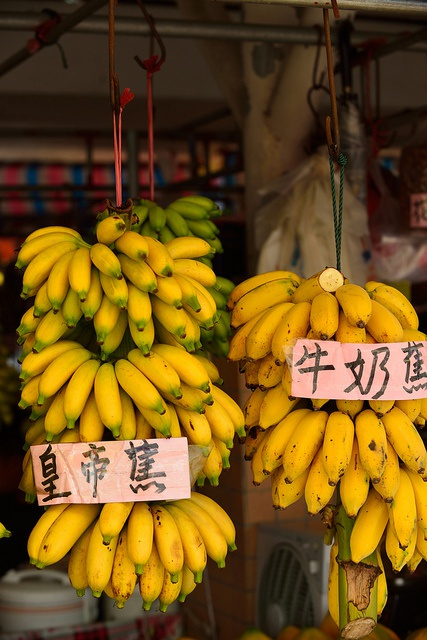Describe the objects in this image and their specific colors. I can see banana in black, orange, and olive tones, banana in black, orange, olive, lightpink, and maroon tones, and banana in black, olive, darkgreen, and maroon tones in this image. 